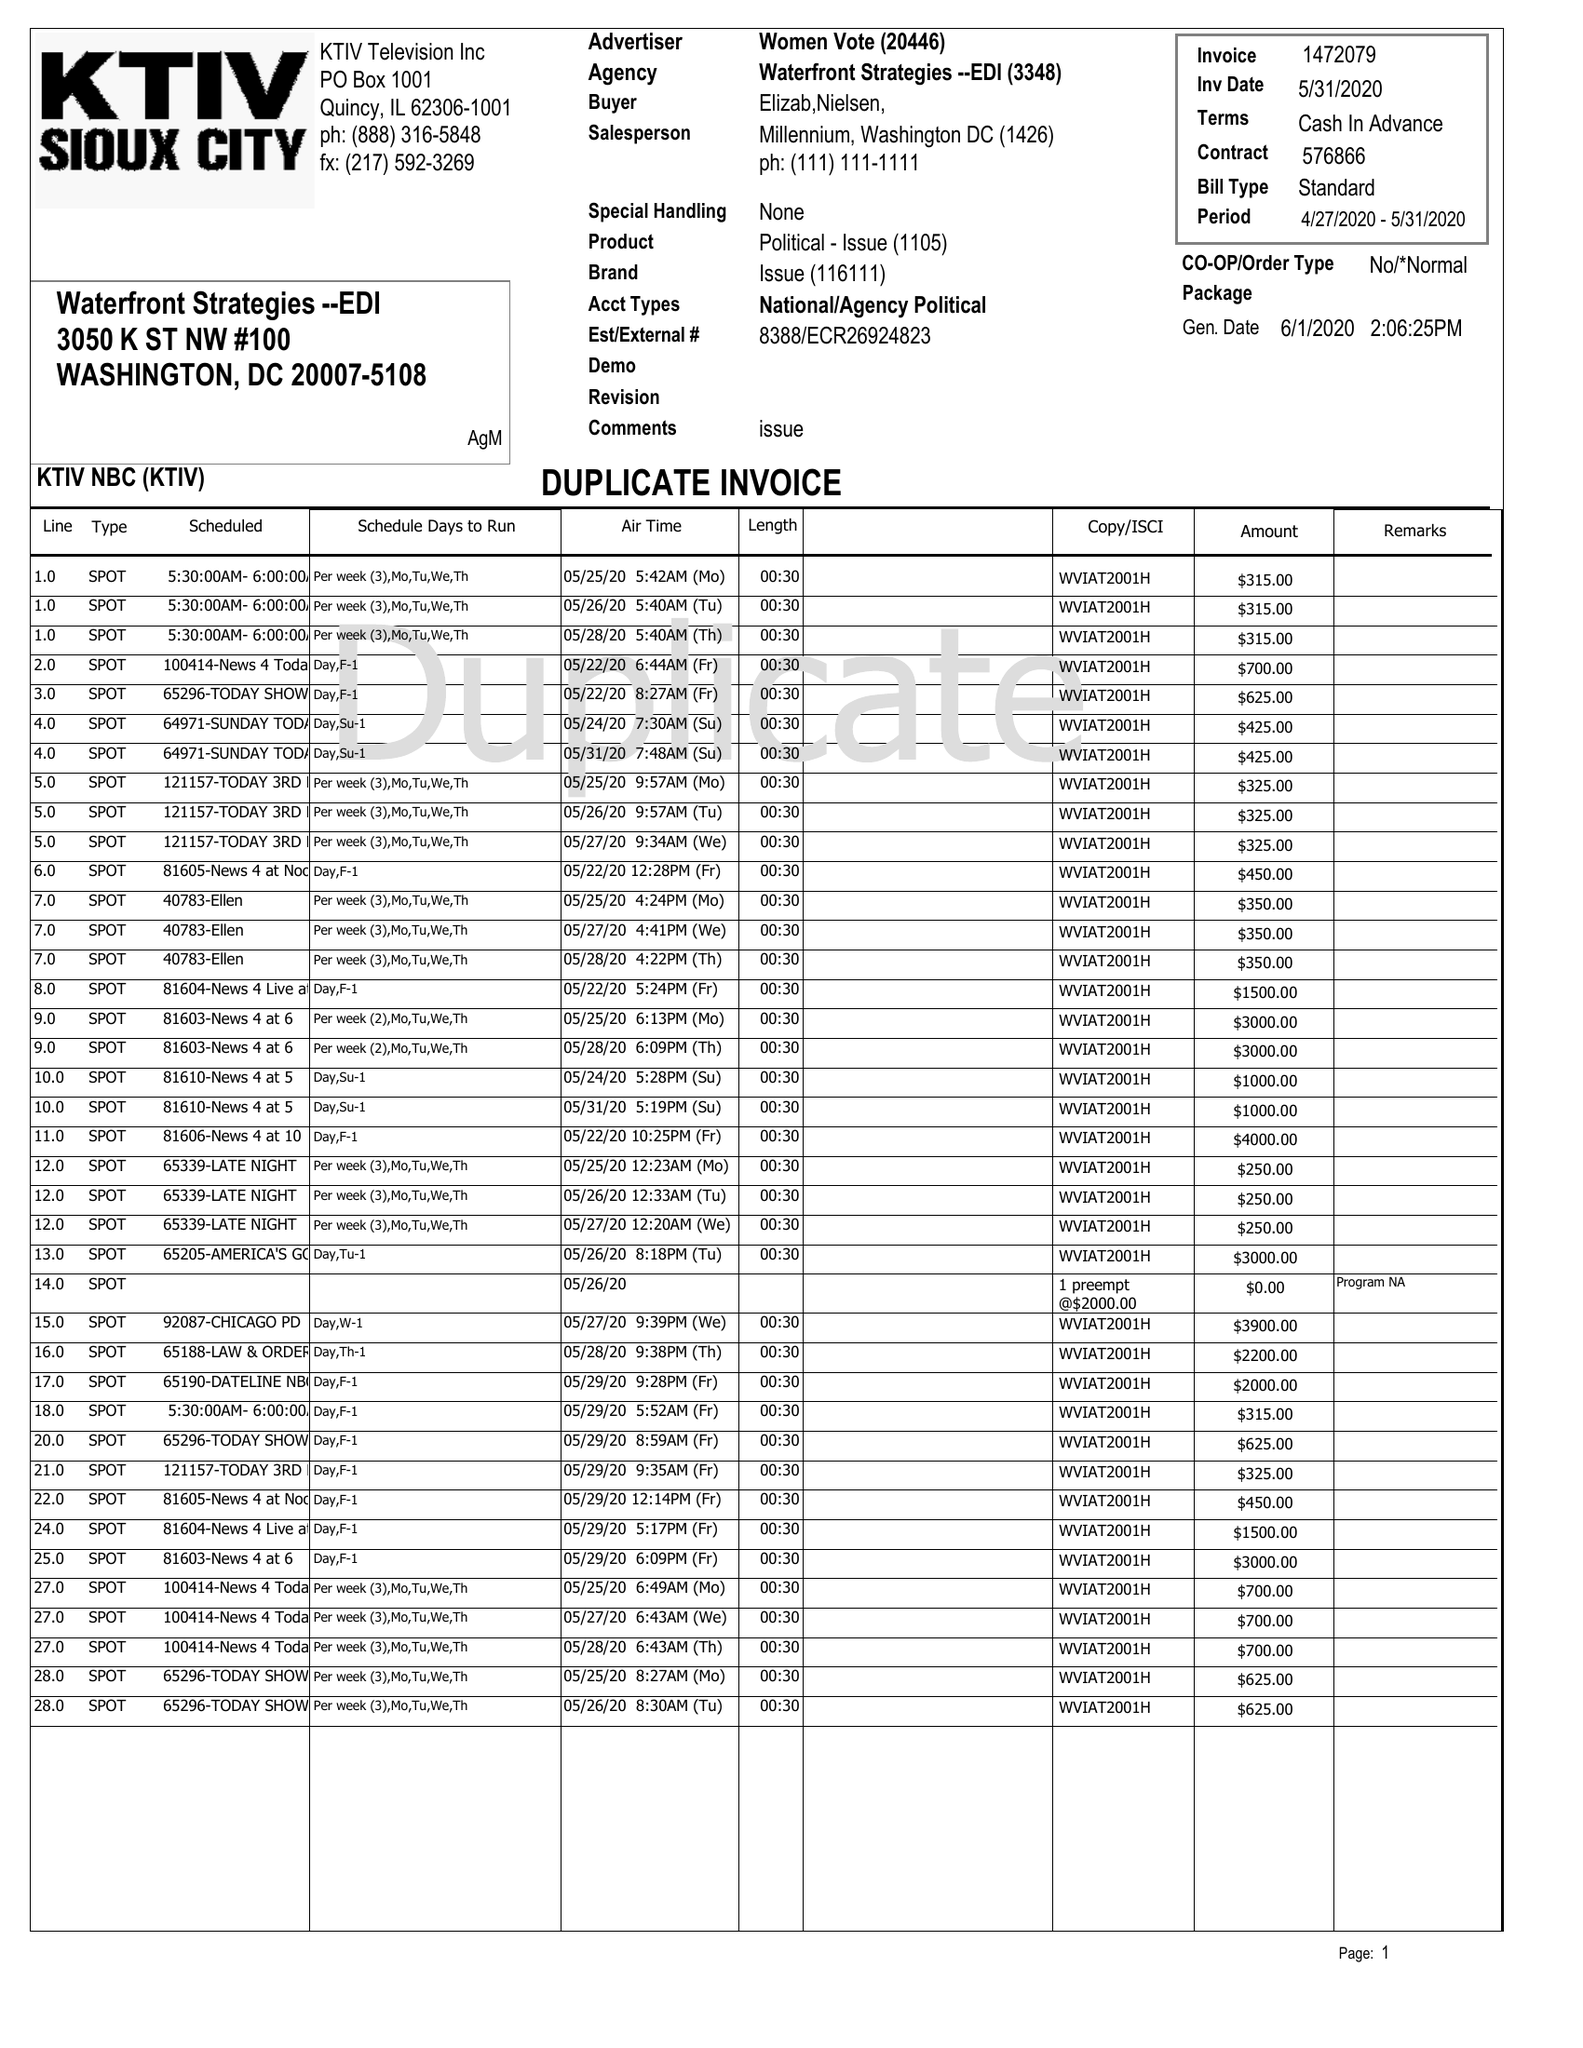What is the value for the contract_num?
Answer the question using a single word or phrase. 1472079 